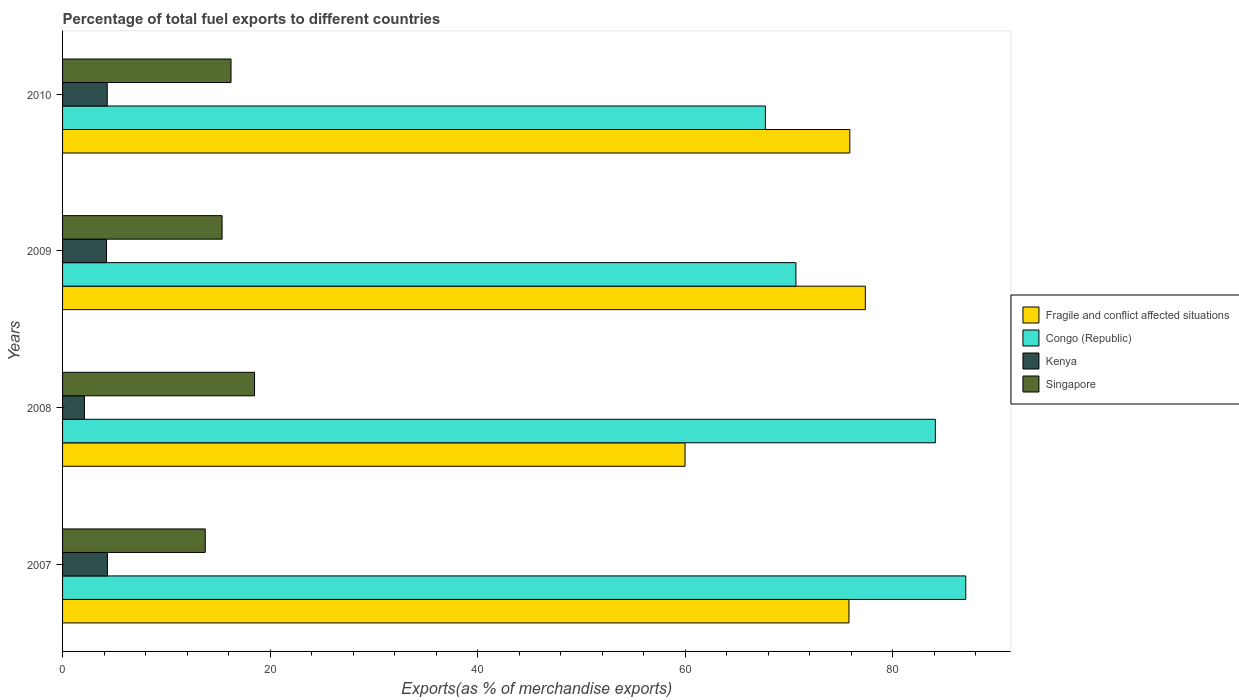How many groups of bars are there?
Ensure brevity in your answer.  4. Are the number of bars on each tick of the Y-axis equal?
Your answer should be very brief. Yes. How many bars are there on the 3rd tick from the top?
Give a very brief answer. 4. How many bars are there on the 2nd tick from the bottom?
Give a very brief answer. 4. What is the label of the 4th group of bars from the top?
Keep it short and to the point. 2007. In how many cases, is the number of bars for a given year not equal to the number of legend labels?
Ensure brevity in your answer.  0. What is the percentage of exports to different countries in Kenya in 2009?
Ensure brevity in your answer.  4.23. Across all years, what is the maximum percentage of exports to different countries in Fragile and conflict affected situations?
Make the answer very short. 77.35. Across all years, what is the minimum percentage of exports to different countries in Singapore?
Your answer should be very brief. 13.75. In which year was the percentage of exports to different countries in Kenya maximum?
Keep it short and to the point. 2007. In which year was the percentage of exports to different countries in Singapore minimum?
Give a very brief answer. 2007. What is the total percentage of exports to different countries in Fragile and conflict affected situations in the graph?
Give a very brief answer. 288.94. What is the difference between the percentage of exports to different countries in Singapore in 2009 and that in 2010?
Keep it short and to the point. -0.86. What is the difference between the percentage of exports to different countries in Congo (Republic) in 2010 and the percentage of exports to different countries in Singapore in 2008?
Your answer should be very brief. 49.22. What is the average percentage of exports to different countries in Congo (Republic) per year?
Offer a terse response. 77.37. In the year 2007, what is the difference between the percentage of exports to different countries in Kenya and percentage of exports to different countries in Congo (Republic)?
Your answer should be very brief. -82.7. What is the ratio of the percentage of exports to different countries in Singapore in 2009 to that in 2010?
Make the answer very short. 0.95. Is the percentage of exports to different countries in Singapore in 2007 less than that in 2010?
Your response must be concise. Yes. Is the difference between the percentage of exports to different countries in Kenya in 2009 and 2010 greater than the difference between the percentage of exports to different countries in Congo (Republic) in 2009 and 2010?
Offer a very short reply. No. What is the difference between the highest and the second highest percentage of exports to different countries in Kenya?
Your answer should be compact. 0.02. What is the difference between the highest and the lowest percentage of exports to different countries in Kenya?
Your response must be concise. 2.22. In how many years, is the percentage of exports to different countries in Kenya greater than the average percentage of exports to different countries in Kenya taken over all years?
Your response must be concise. 3. Is the sum of the percentage of exports to different countries in Congo (Republic) in 2007 and 2009 greater than the maximum percentage of exports to different countries in Kenya across all years?
Keep it short and to the point. Yes. Is it the case that in every year, the sum of the percentage of exports to different countries in Singapore and percentage of exports to different countries in Congo (Republic) is greater than the sum of percentage of exports to different countries in Kenya and percentage of exports to different countries in Fragile and conflict affected situations?
Ensure brevity in your answer.  No. What does the 4th bar from the top in 2008 represents?
Make the answer very short. Fragile and conflict affected situations. What does the 3rd bar from the bottom in 2008 represents?
Keep it short and to the point. Kenya. Is it the case that in every year, the sum of the percentage of exports to different countries in Kenya and percentage of exports to different countries in Fragile and conflict affected situations is greater than the percentage of exports to different countries in Singapore?
Your answer should be compact. Yes. What is the difference between two consecutive major ticks on the X-axis?
Ensure brevity in your answer.  20. Does the graph contain grids?
Your answer should be compact. No. Where does the legend appear in the graph?
Give a very brief answer. Center right. How many legend labels are there?
Make the answer very short. 4. What is the title of the graph?
Ensure brevity in your answer.  Percentage of total fuel exports to different countries. What is the label or title of the X-axis?
Provide a short and direct response. Exports(as % of merchandise exports). What is the label or title of the Y-axis?
Provide a short and direct response. Years. What is the Exports(as % of merchandise exports) of Fragile and conflict affected situations in 2007?
Provide a short and direct response. 75.77. What is the Exports(as % of merchandise exports) of Congo (Republic) in 2007?
Your answer should be compact. 87.02. What is the Exports(as % of merchandise exports) in Kenya in 2007?
Offer a terse response. 4.32. What is the Exports(as % of merchandise exports) of Singapore in 2007?
Ensure brevity in your answer.  13.75. What is the Exports(as % of merchandise exports) in Fragile and conflict affected situations in 2008?
Offer a terse response. 59.98. What is the Exports(as % of merchandise exports) in Congo (Republic) in 2008?
Offer a terse response. 84.09. What is the Exports(as % of merchandise exports) in Kenya in 2008?
Provide a succinct answer. 2.11. What is the Exports(as % of merchandise exports) of Singapore in 2008?
Your answer should be compact. 18.5. What is the Exports(as % of merchandise exports) in Fragile and conflict affected situations in 2009?
Provide a succinct answer. 77.35. What is the Exports(as % of merchandise exports) of Congo (Republic) in 2009?
Keep it short and to the point. 70.66. What is the Exports(as % of merchandise exports) of Kenya in 2009?
Your response must be concise. 4.23. What is the Exports(as % of merchandise exports) in Singapore in 2009?
Keep it short and to the point. 15.37. What is the Exports(as % of merchandise exports) in Fragile and conflict affected situations in 2010?
Ensure brevity in your answer.  75.85. What is the Exports(as % of merchandise exports) in Congo (Republic) in 2010?
Make the answer very short. 67.72. What is the Exports(as % of merchandise exports) of Kenya in 2010?
Your answer should be very brief. 4.3. What is the Exports(as % of merchandise exports) in Singapore in 2010?
Offer a terse response. 16.23. Across all years, what is the maximum Exports(as % of merchandise exports) in Fragile and conflict affected situations?
Offer a very short reply. 77.35. Across all years, what is the maximum Exports(as % of merchandise exports) of Congo (Republic)?
Keep it short and to the point. 87.02. Across all years, what is the maximum Exports(as % of merchandise exports) in Kenya?
Keep it short and to the point. 4.32. Across all years, what is the maximum Exports(as % of merchandise exports) in Singapore?
Offer a very short reply. 18.5. Across all years, what is the minimum Exports(as % of merchandise exports) of Fragile and conflict affected situations?
Keep it short and to the point. 59.98. Across all years, what is the minimum Exports(as % of merchandise exports) in Congo (Republic)?
Ensure brevity in your answer.  67.72. Across all years, what is the minimum Exports(as % of merchandise exports) in Kenya?
Give a very brief answer. 2.11. Across all years, what is the minimum Exports(as % of merchandise exports) in Singapore?
Make the answer very short. 13.75. What is the total Exports(as % of merchandise exports) of Fragile and conflict affected situations in the graph?
Offer a very short reply. 288.94. What is the total Exports(as % of merchandise exports) of Congo (Republic) in the graph?
Provide a succinct answer. 309.5. What is the total Exports(as % of merchandise exports) in Kenya in the graph?
Offer a terse response. 14.96. What is the total Exports(as % of merchandise exports) of Singapore in the graph?
Offer a very short reply. 63.85. What is the difference between the Exports(as % of merchandise exports) in Fragile and conflict affected situations in 2007 and that in 2008?
Make the answer very short. 15.8. What is the difference between the Exports(as % of merchandise exports) in Congo (Republic) in 2007 and that in 2008?
Provide a succinct answer. 2.93. What is the difference between the Exports(as % of merchandise exports) in Kenya in 2007 and that in 2008?
Offer a very short reply. 2.22. What is the difference between the Exports(as % of merchandise exports) in Singapore in 2007 and that in 2008?
Provide a short and direct response. -4.75. What is the difference between the Exports(as % of merchandise exports) of Fragile and conflict affected situations in 2007 and that in 2009?
Your response must be concise. -1.58. What is the difference between the Exports(as % of merchandise exports) in Congo (Republic) in 2007 and that in 2009?
Give a very brief answer. 16.37. What is the difference between the Exports(as % of merchandise exports) in Kenya in 2007 and that in 2009?
Provide a succinct answer. 0.09. What is the difference between the Exports(as % of merchandise exports) in Singapore in 2007 and that in 2009?
Your answer should be compact. -1.62. What is the difference between the Exports(as % of merchandise exports) of Fragile and conflict affected situations in 2007 and that in 2010?
Give a very brief answer. -0.08. What is the difference between the Exports(as % of merchandise exports) in Congo (Republic) in 2007 and that in 2010?
Make the answer very short. 19.3. What is the difference between the Exports(as % of merchandise exports) of Kenya in 2007 and that in 2010?
Your answer should be very brief. 0.02. What is the difference between the Exports(as % of merchandise exports) in Singapore in 2007 and that in 2010?
Offer a terse response. -2.48. What is the difference between the Exports(as % of merchandise exports) in Fragile and conflict affected situations in 2008 and that in 2009?
Keep it short and to the point. -17.37. What is the difference between the Exports(as % of merchandise exports) of Congo (Republic) in 2008 and that in 2009?
Provide a short and direct response. 13.44. What is the difference between the Exports(as % of merchandise exports) of Kenya in 2008 and that in 2009?
Provide a short and direct response. -2.13. What is the difference between the Exports(as % of merchandise exports) in Singapore in 2008 and that in 2009?
Ensure brevity in your answer.  3.13. What is the difference between the Exports(as % of merchandise exports) in Fragile and conflict affected situations in 2008 and that in 2010?
Make the answer very short. -15.88. What is the difference between the Exports(as % of merchandise exports) in Congo (Republic) in 2008 and that in 2010?
Offer a very short reply. 16.37. What is the difference between the Exports(as % of merchandise exports) in Kenya in 2008 and that in 2010?
Provide a succinct answer. -2.19. What is the difference between the Exports(as % of merchandise exports) of Singapore in 2008 and that in 2010?
Your answer should be very brief. 2.27. What is the difference between the Exports(as % of merchandise exports) of Fragile and conflict affected situations in 2009 and that in 2010?
Keep it short and to the point. 1.5. What is the difference between the Exports(as % of merchandise exports) of Congo (Republic) in 2009 and that in 2010?
Offer a terse response. 2.94. What is the difference between the Exports(as % of merchandise exports) in Kenya in 2009 and that in 2010?
Your response must be concise. -0.07. What is the difference between the Exports(as % of merchandise exports) in Singapore in 2009 and that in 2010?
Provide a short and direct response. -0.86. What is the difference between the Exports(as % of merchandise exports) in Fragile and conflict affected situations in 2007 and the Exports(as % of merchandise exports) in Congo (Republic) in 2008?
Keep it short and to the point. -8.32. What is the difference between the Exports(as % of merchandise exports) in Fragile and conflict affected situations in 2007 and the Exports(as % of merchandise exports) in Kenya in 2008?
Provide a short and direct response. 73.66. What is the difference between the Exports(as % of merchandise exports) of Fragile and conflict affected situations in 2007 and the Exports(as % of merchandise exports) of Singapore in 2008?
Provide a succinct answer. 57.27. What is the difference between the Exports(as % of merchandise exports) of Congo (Republic) in 2007 and the Exports(as % of merchandise exports) of Kenya in 2008?
Keep it short and to the point. 84.92. What is the difference between the Exports(as % of merchandise exports) in Congo (Republic) in 2007 and the Exports(as % of merchandise exports) in Singapore in 2008?
Your answer should be very brief. 68.53. What is the difference between the Exports(as % of merchandise exports) of Kenya in 2007 and the Exports(as % of merchandise exports) of Singapore in 2008?
Your answer should be very brief. -14.18. What is the difference between the Exports(as % of merchandise exports) in Fragile and conflict affected situations in 2007 and the Exports(as % of merchandise exports) in Congo (Republic) in 2009?
Offer a very short reply. 5.11. What is the difference between the Exports(as % of merchandise exports) of Fragile and conflict affected situations in 2007 and the Exports(as % of merchandise exports) of Kenya in 2009?
Offer a very short reply. 71.54. What is the difference between the Exports(as % of merchandise exports) of Fragile and conflict affected situations in 2007 and the Exports(as % of merchandise exports) of Singapore in 2009?
Ensure brevity in your answer.  60.4. What is the difference between the Exports(as % of merchandise exports) of Congo (Republic) in 2007 and the Exports(as % of merchandise exports) of Kenya in 2009?
Your answer should be very brief. 82.79. What is the difference between the Exports(as % of merchandise exports) of Congo (Republic) in 2007 and the Exports(as % of merchandise exports) of Singapore in 2009?
Your answer should be very brief. 71.66. What is the difference between the Exports(as % of merchandise exports) in Kenya in 2007 and the Exports(as % of merchandise exports) in Singapore in 2009?
Your response must be concise. -11.05. What is the difference between the Exports(as % of merchandise exports) in Fragile and conflict affected situations in 2007 and the Exports(as % of merchandise exports) in Congo (Republic) in 2010?
Your answer should be very brief. 8.05. What is the difference between the Exports(as % of merchandise exports) in Fragile and conflict affected situations in 2007 and the Exports(as % of merchandise exports) in Kenya in 2010?
Your answer should be very brief. 71.47. What is the difference between the Exports(as % of merchandise exports) of Fragile and conflict affected situations in 2007 and the Exports(as % of merchandise exports) of Singapore in 2010?
Make the answer very short. 59.54. What is the difference between the Exports(as % of merchandise exports) of Congo (Republic) in 2007 and the Exports(as % of merchandise exports) of Kenya in 2010?
Make the answer very short. 82.72. What is the difference between the Exports(as % of merchandise exports) of Congo (Republic) in 2007 and the Exports(as % of merchandise exports) of Singapore in 2010?
Your response must be concise. 70.79. What is the difference between the Exports(as % of merchandise exports) of Kenya in 2007 and the Exports(as % of merchandise exports) of Singapore in 2010?
Offer a very short reply. -11.91. What is the difference between the Exports(as % of merchandise exports) in Fragile and conflict affected situations in 2008 and the Exports(as % of merchandise exports) in Congo (Republic) in 2009?
Provide a succinct answer. -10.68. What is the difference between the Exports(as % of merchandise exports) of Fragile and conflict affected situations in 2008 and the Exports(as % of merchandise exports) of Kenya in 2009?
Offer a very short reply. 55.74. What is the difference between the Exports(as % of merchandise exports) of Fragile and conflict affected situations in 2008 and the Exports(as % of merchandise exports) of Singapore in 2009?
Offer a very short reply. 44.61. What is the difference between the Exports(as % of merchandise exports) in Congo (Republic) in 2008 and the Exports(as % of merchandise exports) in Kenya in 2009?
Make the answer very short. 79.86. What is the difference between the Exports(as % of merchandise exports) of Congo (Republic) in 2008 and the Exports(as % of merchandise exports) of Singapore in 2009?
Your response must be concise. 68.72. What is the difference between the Exports(as % of merchandise exports) in Kenya in 2008 and the Exports(as % of merchandise exports) in Singapore in 2009?
Make the answer very short. -13.26. What is the difference between the Exports(as % of merchandise exports) in Fragile and conflict affected situations in 2008 and the Exports(as % of merchandise exports) in Congo (Republic) in 2010?
Offer a terse response. -7.75. What is the difference between the Exports(as % of merchandise exports) in Fragile and conflict affected situations in 2008 and the Exports(as % of merchandise exports) in Kenya in 2010?
Ensure brevity in your answer.  55.67. What is the difference between the Exports(as % of merchandise exports) of Fragile and conflict affected situations in 2008 and the Exports(as % of merchandise exports) of Singapore in 2010?
Your response must be concise. 43.74. What is the difference between the Exports(as % of merchandise exports) of Congo (Republic) in 2008 and the Exports(as % of merchandise exports) of Kenya in 2010?
Ensure brevity in your answer.  79.79. What is the difference between the Exports(as % of merchandise exports) of Congo (Republic) in 2008 and the Exports(as % of merchandise exports) of Singapore in 2010?
Give a very brief answer. 67.86. What is the difference between the Exports(as % of merchandise exports) in Kenya in 2008 and the Exports(as % of merchandise exports) in Singapore in 2010?
Offer a very short reply. -14.12. What is the difference between the Exports(as % of merchandise exports) of Fragile and conflict affected situations in 2009 and the Exports(as % of merchandise exports) of Congo (Republic) in 2010?
Provide a succinct answer. 9.63. What is the difference between the Exports(as % of merchandise exports) of Fragile and conflict affected situations in 2009 and the Exports(as % of merchandise exports) of Kenya in 2010?
Provide a short and direct response. 73.05. What is the difference between the Exports(as % of merchandise exports) in Fragile and conflict affected situations in 2009 and the Exports(as % of merchandise exports) in Singapore in 2010?
Keep it short and to the point. 61.12. What is the difference between the Exports(as % of merchandise exports) in Congo (Republic) in 2009 and the Exports(as % of merchandise exports) in Kenya in 2010?
Make the answer very short. 66.36. What is the difference between the Exports(as % of merchandise exports) of Congo (Republic) in 2009 and the Exports(as % of merchandise exports) of Singapore in 2010?
Your answer should be compact. 54.43. What is the difference between the Exports(as % of merchandise exports) in Kenya in 2009 and the Exports(as % of merchandise exports) in Singapore in 2010?
Keep it short and to the point. -12. What is the average Exports(as % of merchandise exports) of Fragile and conflict affected situations per year?
Your response must be concise. 72.24. What is the average Exports(as % of merchandise exports) of Congo (Republic) per year?
Make the answer very short. 77.37. What is the average Exports(as % of merchandise exports) in Kenya per year?
Give a very brief answer. 3.74. What is the average Exports(as % of merchandise exports) of Singapore per year?
Provide a short and direct response. 15.96. In the year 2007, what is the difference between the Exports(as % of merchandise exports) in Fragile and conflict affected situations and Exports(as % of merchandise exports) in Congo (Republic)?
Make the answer very short. -11.25. In the year 2007, what is the difference between the Exports(as % of merchandise exports) in Fragile and conflict affected situations and Exports(as % of merchandise exports) in Kenya?
Keep it short and to the point. 71.45. In the year 2007, what is the difference between the Exports(as % of merchandise exports) in Fragile and conflict affected situations and Exports(as % of merchandise exports) in Singapore?
Give a very brief answer. 62.02. In the year 2007, what is the difference between the Exports(as % of merchandise exports) in Congo (Republic) and Exports(as % of merchandise exports) in Kenya?
Offer a terse response. 82.7. In the year 2007, what is the difference between the Exports(as % of merchandise exports) in Congo (Republic) and Exports(as % of merchandise exports) in Singapore?
Offer a very short reply. 73.27. In the year 2007, what is the difference between the Exports(as % of merchandise exports) in Kenya and Exports(as % of merchandise exports) in Singapore?
Make the answer very short. -9.43. In the year 2008, what is the difference between the Exports(as % of merchandise exports) in Fragile and conflict affected situations and Exports(as % of merchandise exports) in Congo (Republic)?
Your answer should be compact. -24.12. In the year 2008, what is the difference between the Exports(as % of merchandise exports) of Fragile and conflict affected situations and Exports(as % of merchandise exports) of Kenya?
Your answer should be very brief. 57.87. In the year 2008, what is the difference between the Exports(as % of merchandise exports) in Fragile and conflict affected situations and Exports(as % of merchandise exports) in Singapore?
Keep it short and to the point. 41.48. In the year 2008, what is the difference between the Exports(as % of merchandise exports) in Congo (Republic) and Exports(as % of merchandise exports) in Kenya?
Offer a very short reply. 81.99. In the year 2008, what is the difference between the Exports(as % of merchandise exports) in Congo (Republic) and Exports(as % of merchandise exports) in Singapore?
Provide a succinct answer. 65.6. In the year 2008, what is the difference between the Exports(as % of merchandise exports) in Kenya and Exports(as % of merchandise exports) in Singapore?
Ensure brevity in your answer.  -16.39. In the year 2009, what is the difference between the Exports(as % of merchandise exports) in Fragile and conflict affected situations and Exports(as % of merchandise exports) in Congo (Republic)?
Ensure brevity in your answer.  6.69. In the year 2009, what is the difference between the Exports(as % of merchandise exports) of Fragile and conflict affected situations and Exports(as % of merchandise exports) of Kenya?
Give a very brief answer. 73.11. In the year 2009, what is the difference between the Exports(as % of merchandise exports) in Fragile and conflict affected situations and Exports(as % of merchandise exports) in Singapore?
Offer a terse response. 61.98. In the year 2009, what is the difference between the Exports(as % of merchandise exports) in Congo (Republic) and Exports(as % of merchandise exports) in Kenya?
Offer a terse response. 66.43. In the year 2009, what is the difference between the Exports(as % of merchandise exports) of Congo (Republic) and Exports(as % of merchandise exports) of Singapore?
Your response must be concise. 55.29. In the year 2009, what is the difference between the Exports(as % of merchandise exports) in Kenya and Exports(as % of merchandise exports) in Singapore?
Your response must be concise. -11.14. In the year 2010, what is the difference between the Exports(as % of merchandise exports) of Fragile and conflict affected situations and Exports(as % of merchandise exports) of Congo (Republic)?
Make the answer very short. 8.13. In the year 2010, what is the difference between the Exports(as % of merchandise exports) of Fragile and conflict affected situations and Exports(as % of merchandise exports) of Kenya?
Offer a very short reply. 71.55. In the year 2010, what is the difference between the Exports(as % of merchandise exports) in Fragile and conflict affected situations and Exports(as % of merchandise exports) in Singapore?
Offer a terse response. 59.62. In the year 2010, what is the difference between the Exports(as % of merchandise exports) in Congo (Republic) and Exports(as % of merchandise exports) in Kenya?
Make the answer very short. 63.42. In the year 2010, what is the difference between the Exports(as % of merchandise exports) in Congo (Republic) and Exports(as % of merchandise exports) in Singapore?
Offer a terse response. 51.49. In the year 2010, what is the difference between the Exports(as % of merchandise exports) in Kenya and Exports(as % of merchandise exports) in Singapore?
Your answer should be compact. -11.93. What is the ratio of the Exports(as % of merchandise exports) in Fragile and conflict affected situations in 2007 to that in 2008?
Offer a terse response. 1.26. What is the ratio of the Exports(as % of merchandise exports) in Congo (Republic) in 2007 to that in 2008?
Your answer should be very brief. 1.03. What is the ratio of the Exports(as % of merchandise exports) of Kenya in 2007 to that in 2008?
Give a very brief answer. 2.05. What is the ratio of the Exports(as % of merchandise exports) in Singapore in 2007 to that in 2008?
Provide a succinct answer. 0.74. What is the ratio of the Exports(as % of merchandise exports) of Fragile and conflict affected situations in 2007 to that in 2009?
Keep it short and to the point. 0.98. What is the ratio of the Exports(as % of merchandise exports) in Congo (Republic) in 2007 to that in 2009?
Keep it short and to the point. 1.23. What is the ratio of the Exports(as % of merchandise exports) in Kenya in 2007 to that in 2009?
Your answer should be very brief. 1.02. What is the ratio of the Exports(as % of merchandise exports) of Singapore in 2007 to that in 2009?
Provide a short and direct response. 0.89. What is the ratio of the Exports(as % of merchandise exports) of Fragile and conflict affected situations in 2007 to that in 2010?
Offer a very short reply. 1. What is the ratio of the Exports(as % of merchandise exports) in Congo (Republic) in 2007 to that in 2010?
Ensure brevity in your answer.  1.29. What is the ratio of the Exports(as % of merchandise exports) of Singapore in 2007 to that in 2010?
Ensure brevity in your answer.  0.85. What is the ratio of the Exports(as % of merchandise exports) in Fragile and conflict affected situations in 2008 to that in 2009?
Your answer should be very brief. 0.78. What is the ratio of the Exports(as % of merchandise exports) of Congo (Republic) in 2008 to that in 2009?
Your answer should be compact. 1.19. What is the ratio of the Exports(as % of merchandise exports) in Kenya in 2008 to that in 2009?
Give a very brief answer. 0.5. What is the ratio of the Exports(as % of merchandise exports) of Singapore in 2008 to that in 2009?
Ensure brevity in your answer.  1.2. What is the ratio of the Exports(as % of merchandise exports) in Fragile and conflict affected situations in 2008 to that in 2010?
Keep it short and to the point. 0.79. What is the ratio of the Exports(as % of merchandise exports) in Congo (Republic) in 2008 to that in 2010?
Provide a short and direct response. 1.24. What is the ratio of the Exports(as % of merchandise exports) of Kenya in 2008 to that in 2010?
Your response must be concise. 0.49. What is the ratio of the Exports(as % of merchandise exports) in Singapore in 2008 to that in 2010?
Offer a terse response. 1.14. What is the ratio of the Exports(as % of merchandise exports) of Fragile and conflict affected situations in 2009 to that in 2010?
Offer a very short reply. 1.02. What is the ratio of the Exports(as % of merchandise exports) of Congo (Republic) in 2009 to that in 2010?
Make the answer very short. 1.04. What is the ratio of the Exports(as % of merchandise exports) of Kenya in 2009 to that in 2010?
Give a very brief answer. 0.98. What is the ratio of the Exports(as % of merchandise exports) in Singapore in 2009 to that in 2010?
Your answer should be very brief. 0.95. What is the difference between the highest and the second highest Exports(as % of merchandise exports) of Fragile and conflict affected situations?
Your response must be concise. 1.5. What is the difference between the highest and the second highest Exports(as % of merchandise exports) of Congo (Republic)?
Your answer should be very brief. 2.93. What is the difference between the highest and the second highest Exports(as % of merchandise exports) in Kenya?
Provide a short and direct response. 0.02. What is the difference between the highest and the second highest Exports(as % of merchandise exports) of Singapore?
Give a very brief answer. 2.27. What is the difference between the highest and the lowest Exports(as % of merchandise exports) of Fragile and conflict affected situations?
Provide a succinct answer. 17.37. What is the difference between the highest and the lowest Exports(as % of merchandise exports) in Congo (Republic)?
Provide a succinct answer. 19.3. What is the difference between the highest and the lowest Exports(as % of merchandise exports) in Kenya?
Provide a succinct answer. 2.22. What is the difference between the highest and the lowest Exports(as % of merchandise exports) in Singapore?
Your answer should be compact. 4.75. 